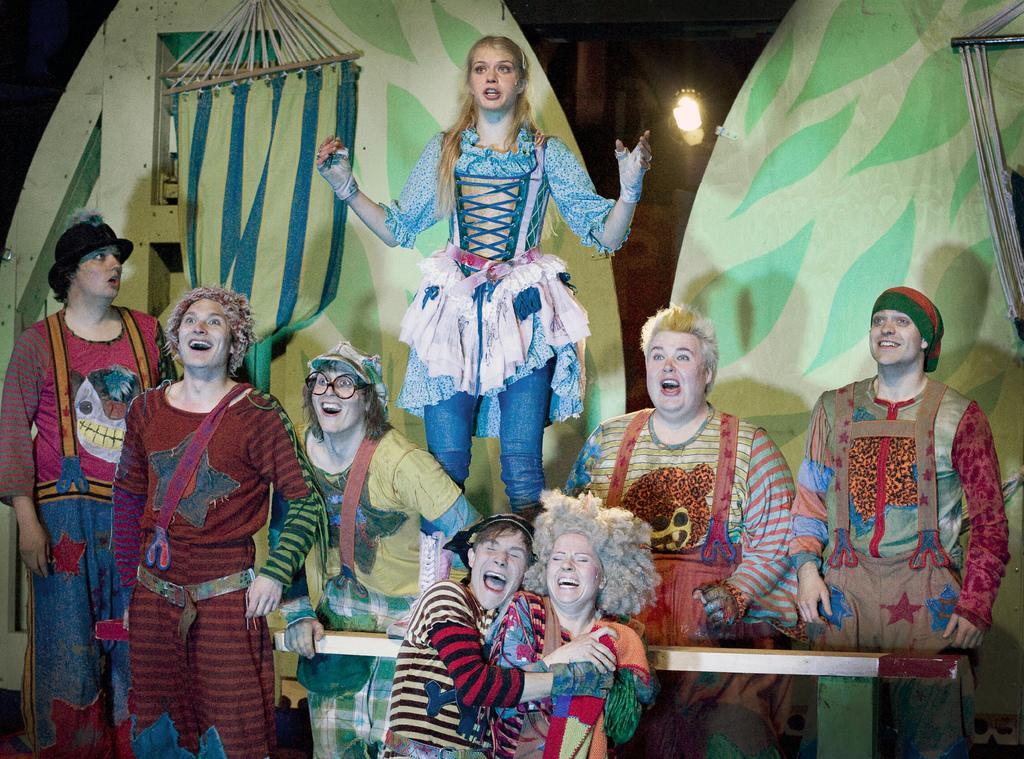In one or two sentences, can you explain what this image depicts? In this image I can see group of people and they are wearing multi color dresses. In the background I can see the board in green color and I can see the light. 